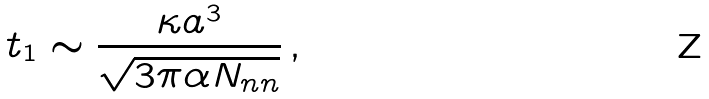<formula> <loc_0><loc_0><loc_500><loc_500>t _ { 1 } \sim \frac { \kappa a ^ { 3 } } { \sqrt { 3 \pi \alpha N _ { n n } } } \, ,</formula> 